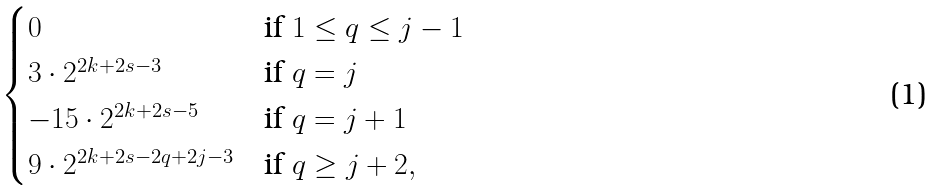Convert formula to latex. <formula><loc_0><loc_0><loc_500><loc_500>\begin{cases} 0 & \text {if } 1 \leq q \leq j - 1 \\ 3 \cdot 2 ^ { 2 k + 2 s - 3 } & \text {if } q = j \\ - 1 5 \cdot 2 ^ { 2 k + 2 s - 5 } & \text {if } q = j + 1 \\ 9 \cdot 2 ^ { 2 k + 2 s - 2 q + 2 j - 3 } & \text {if } q \geq j + 2 , \end{cases}</formula> 